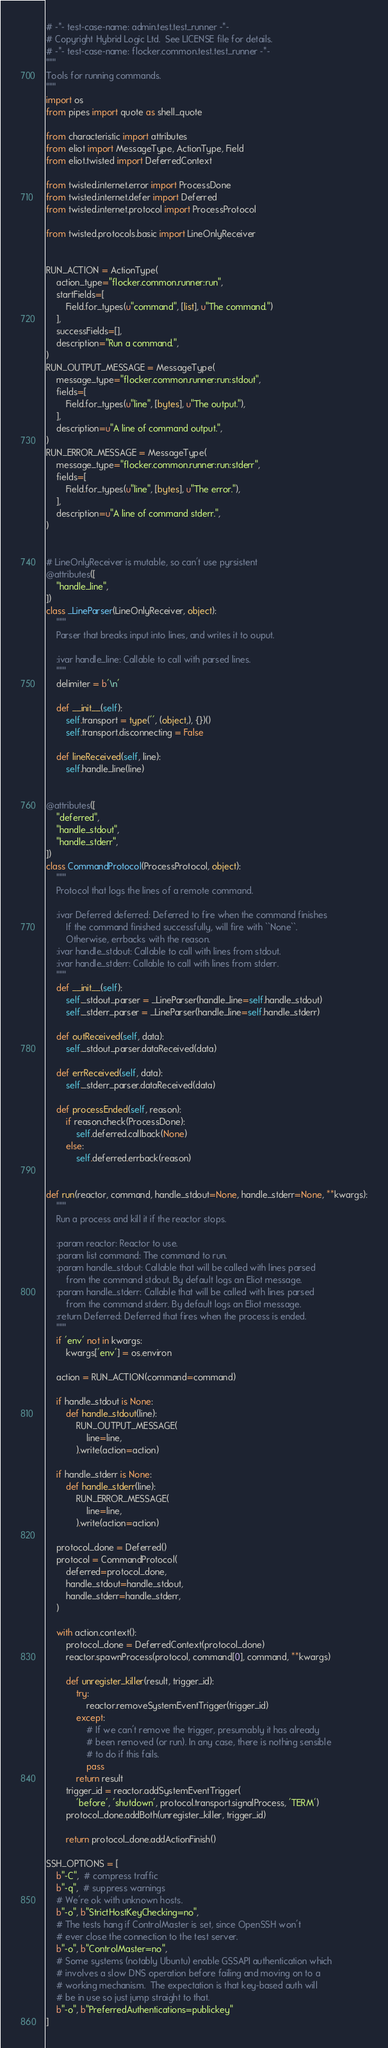<code> <loc_0><loc_0><loc_500><loc_500><_Python_># -*- test-case-name: admin.test.test_runner -*-
# Copyright Hybrid Logic Ltd.  See LICENSE file for details.
# -*- test-case-name: flocker.common.test.test_runner -*-
"""
Tools for running commands.
"""
import os
from pipes import quote as shell_quote

from characteristic import attributes
from eliot import MessageType, ActionType, Field
from eliot.twisted import DeferredContext

from twisted.internet.error import ProcessDone
from twisted.internet.defer import Deferred
from twisted.internet.protocol import ProcessProtocol

from twisted.protocols.basic import LineOnlyReceiver


RUN_ACTION = ActionType(
    action_type="flocker.common.runner:run",
    startFields=[
        Field.for_types(u"command", [list], u"The command.")
    ],
    successFields=[],
    description="Run a command.",
)
RUN_OUTPUT_MESSAGE = MessageType(
    message_type="flocker.common.runner:run:stdout",
    fields=[
        Field.for_types(u"line", [bytes], u"The output."),
    ],
    description=u"A line of command output.",
)
RUN_ERROR_MESSAGE = MessageType(
    message_type="flocker.common.runner:run:stderr",
    fields=[
        Field.for_types(u"line", [bytes], u"The error."),
    ],
    description=u"A line of command stderr.",
)


# LineOnlyReceiver is mutable, so can't use pyrsistent
@attributes([
    "handle_line",
])
class _LineParser(LineOnlyReceiver, object):
    """
    Parser that breaks input into lines, and writes it to ouput.

    :ivar handle_line: Callable to call with parsed lines.
    """
    delimiter = b'\n'

    def __init__(self):
        self.transport = type('', (object,), {})()
        self.transport.disconnecting = False

    def lineReceived(self, line):
        self.handle_line(line)


@attributes([
    "deferred",
    "handle_stdout",
    "handle_stderr",
])
class CommandProtocol(ProcessProtocol, object):
    """
    Protocol that logs the lines of a remote command.

    :ivar Deferred deferred: Deferred to fire when the command finishes
        If the command finished successfully, will fire with ``None``.
        Otherwise, errbacks with the reason.
    :ivar handle_stdout: Callable to call with lines from stdout.
    :ivar handle_stderr: Callable to call with lines from stderr.
    """
    def __init__(self):
        self._stdout_parser = _LineParser(handle_line=self.handle_stdout)
        self._stderr_parser = _LineParser(handle_line=self.handle_stderr)

    def outReceived(self, data):
        self._stdout_parser.dataReceived(data)

    def errReceived(self, data):
        self._stderr_parser.dataReceived(data)

    def processEnded(self, reason):
        if reason.check(ProcessDone):
            self.deferred.callback(None)
        else:
            self.deferred.errback(reason)


def run(reactor, command, handle_stdout=None, handle_stderr=None, **kwargs):
    """
    Run a process and kill it if the reactor stops.

    :param reactor: Reactor to use.
    :param list command: The command to run.
    :param handle_stdout: Callable that will be called with lines parsed
        from the command stdout. By default logs an Eliot message.
    :param handle_stderr: Callable that will be called with lines parsed
        from the command stderr. By default logs an Eliot message.
    :return Deferred: Deferred that fires when the process is ended.
    """
    if 'env' not in kwargs:
        kwargs['env'] = os.environ

    action = RUN_ACTION(command=command)

    if handle_stdout is None:
        def handle_stdout(line):
            RUN_OUTPUT_MESSAGE(
                line=line,
            ).write(action=action)

    if handle_stderr is None:
        def handle_stderr(line):
            RUN_ERROR_MESSAGE(
                line=line,
            ).write(action=action)

    protocol_done = Deferred()
    protocol = CommandProtocol(
        deferred=protocol_done,
        handle_stdout=handle_stdout,
        handle_stderr=handle_stderr,
    )

    with action.context():
        protocol_done = DeferredContext(protocol_done)
        reactor.spawnProcess(protocol, command[0], command, **kwargs)

        def unregister_killer(result, trigger_id):
            try:
                reactor.removeSystemEventTrigger(trigger_id)
            except:
                # If we can't remove the trigger, presumably it has already
                # been removed (or run). In any case, there is nothing sensible
                # to do if this fails.
                pass
            return result
        trigger_id = reactor.addSystemEventTrigger(
            'before', 'shutdown', protocol.transport.signalProcess, 'TERM')
        protocol_done.addBoth(unregister_killer, trigger_id)

        return protocol_done.addActionFinish()

SSH_OPTIONS = [
    b"-C",  # compress traffic
    b"-q",  # suppress warnings
    # We're ok with unknown hosts.
    b"-o", b"StrictHostKeyChecking=no",
    # The tests hang if ControlMaster is set, since OpenSSH won't
    # ever close the connection to the test server.
    b"-o", b"ControlMaster=no",
    # Some systems (notably Ubuntu) enable GSSAPI authentication which
    # involves a slow DNS operation before failing and moving on to a
    # working mechanism.  The expectation is that key-based auth will
    # be in use so just jump straight to that.
    b"-o", b"PreferredAuthentications=publickey"
]

</code> 